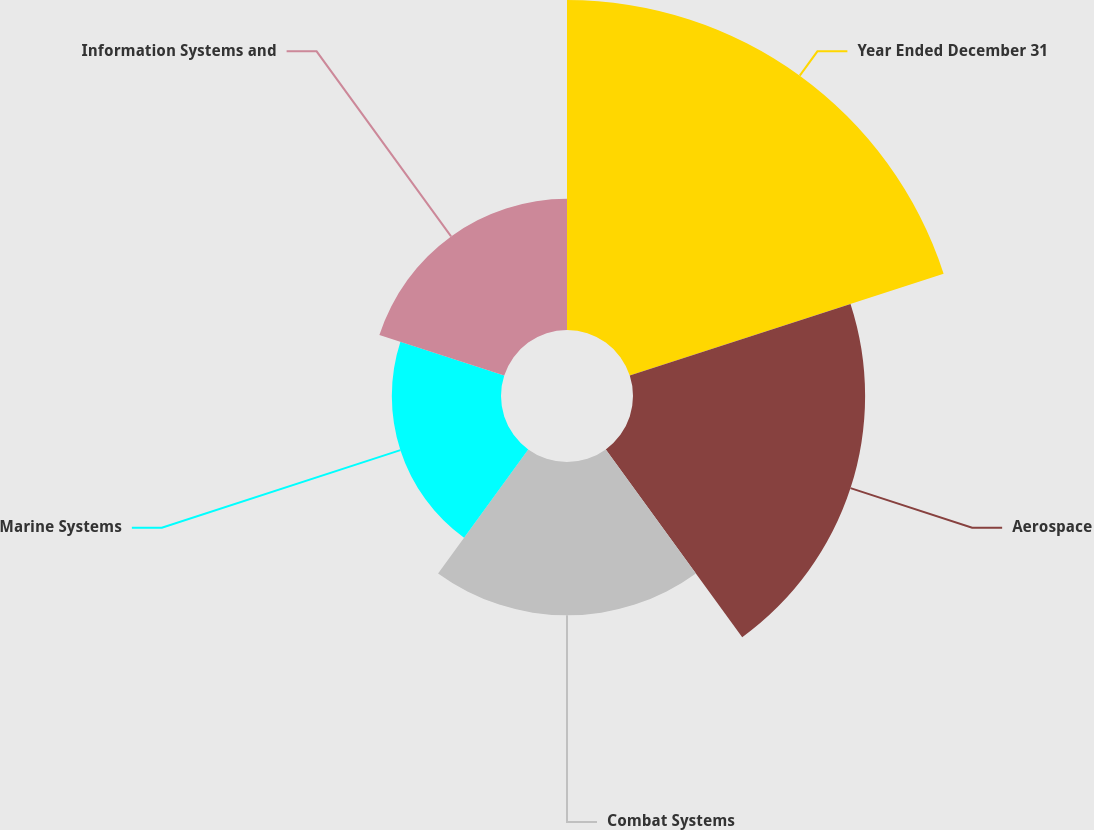Convert chart to OTSL. <chart><loc_0><loc_0><loc_500><loc_500><pie_chart><fcel>Year Ended December 31<fcel>Aerospace<fcel>Combat Systems<fcel>Marine Systems<fcel>Information Systems and<nl><fcel>34.52%<fcel>24.28%<fcel>16.04%<fcel>11.42%<fcel>13.73%<nl></chart> 